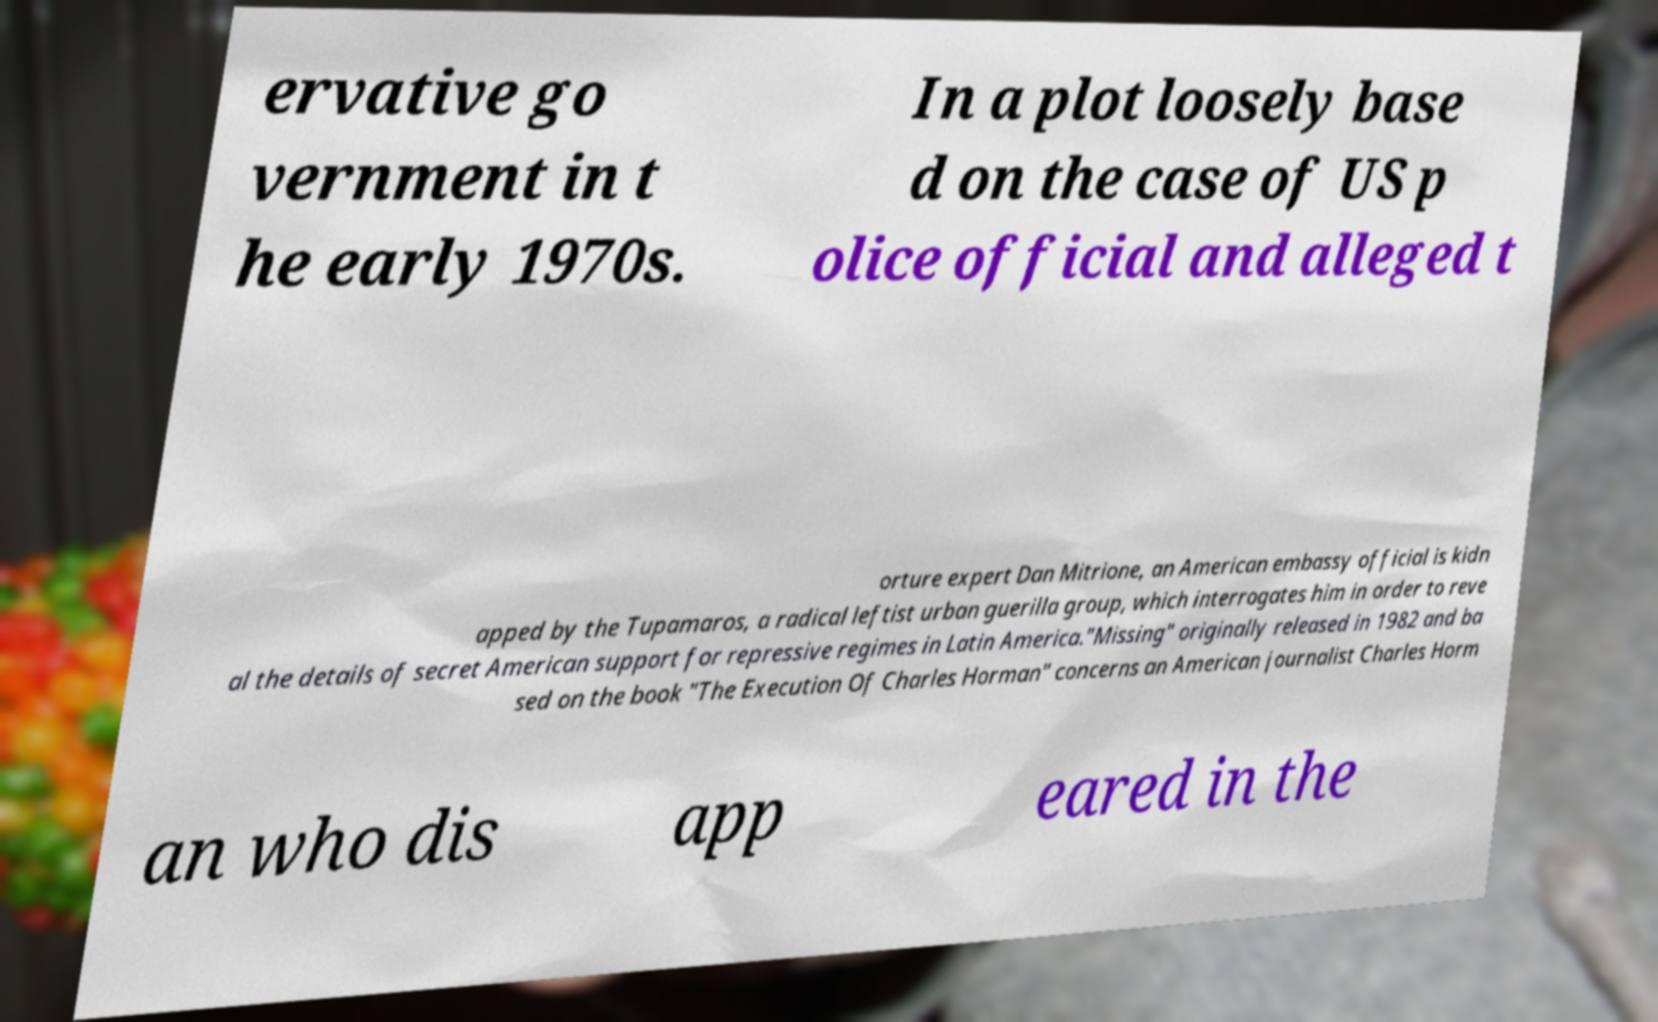There's text embedded in this image that I need extracted. Can you transcribe it verbatim? ervative go vernment in t he early 1970s. In a plot loosely base d on the case of US p olice official and alleged t orture expert Dan Mitrione, an American embassy official is kidn apped by the Tupamaros, a radical leftist urban guerilla group, which interrogates him in order to reve al the details of secret American support for repressive regimes in Latin America."Missing" originally released in 1982 and ba sed on the book "The Execution Of Charles Horman" concerns an American journalist Charles Horm an who dis app eared in the 